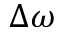<formula> <loc_0><loc_0><loc_500><loc_500>\Delta \omega</formula> 